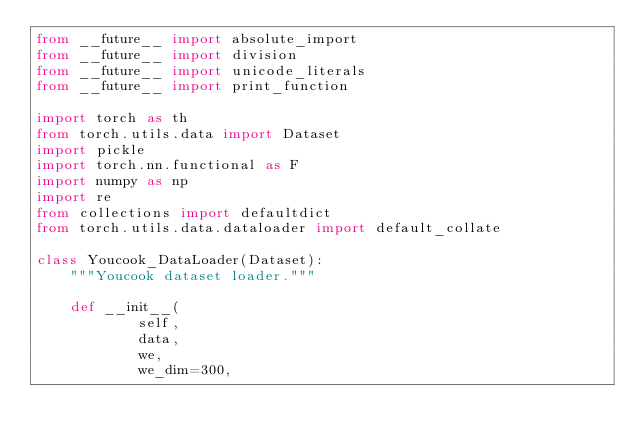<code> <loc_0><loc_0><loc_500><loc_500><_Python_>from __future__ import absolute_import
from __future__ import division
from __future__ import unicode_literals
from __future__ import print_function

import torch as th
from torch.utils.data import Dataset
import pickle
import torch.nn.functional as F
import numpy as np
import re
from collections import defaultdict
from torch.utils.data.dataloader import default_collate

class Youcook_DataLoader(Dataset):
    """Youcook dataset loader."""

    def __init__(
            self,
            data,
            we,
            we_dim=300,</code> 